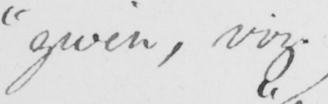Transcribe the text shown in this historical manuscript line. " given , viz . 